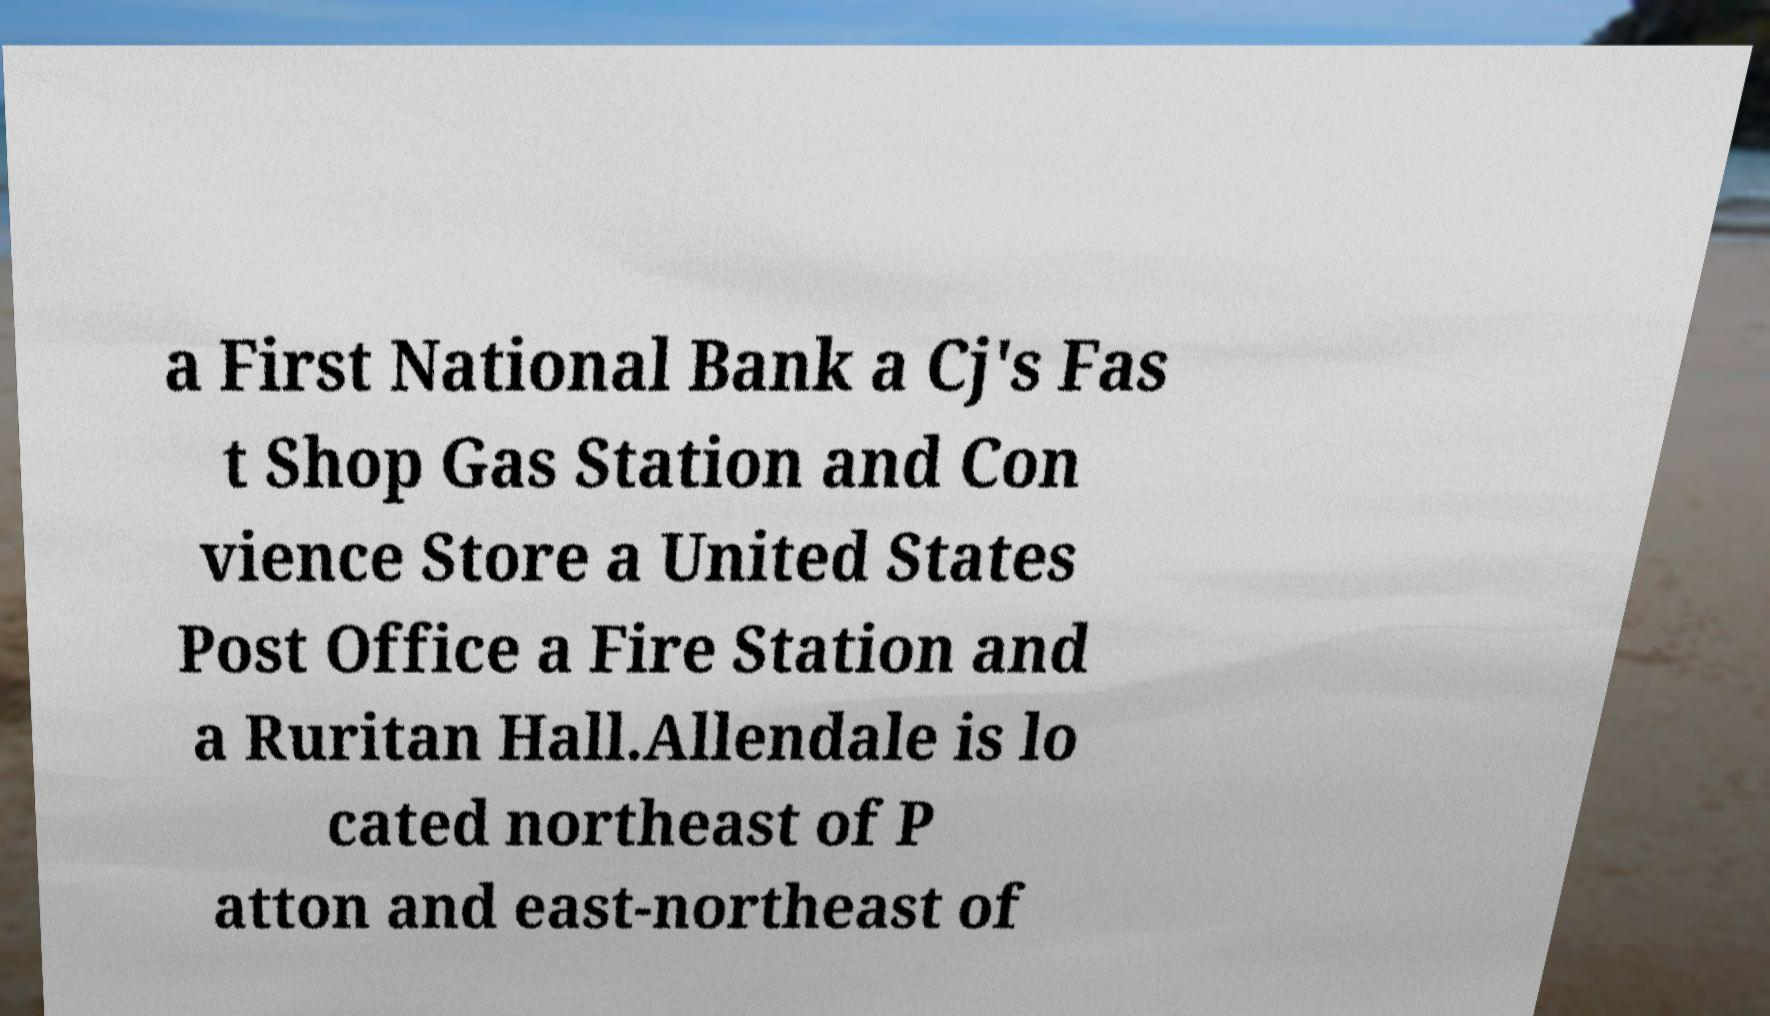I need the written content from this picture converted into text. Can you do that? a First National Bank a Cj's Fas t Shop Gas Station and Con vience Store a United States Post Office a Fire Station and a Ruritan Hall.Allendale is lo cated northeast of P atton and east-northeast of 